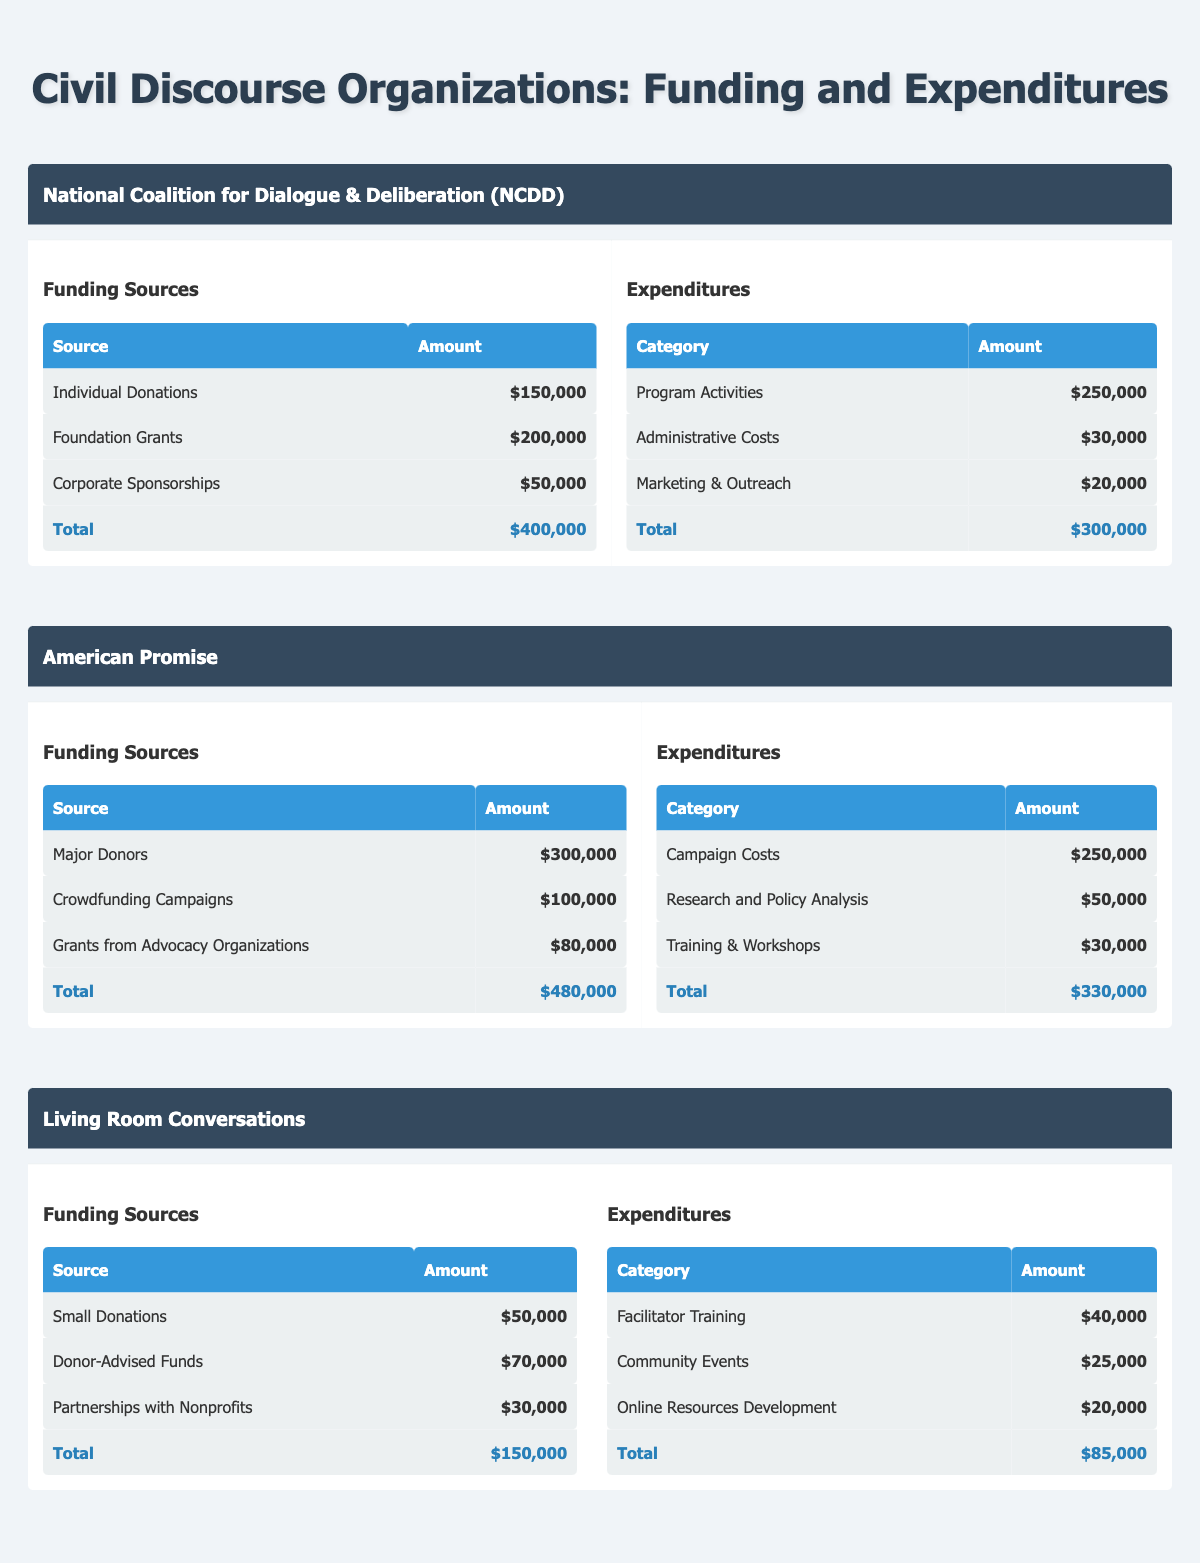What is the total funding for the National Coalition for Dialogue & Deliberation? The funding sources for NCDD are: Individual Donations ($150,000), Foundation Grants ($200,000), and Corporate Sponsorships ($50,000). Adding these amounts gives us a total of $150,000 + $200,000 + $50,000 = $400,000.
Answer: $400,000 What are the expenditures for Living Room Conversations? The expenditures for Living Room Conversations are: Facilitator Training ($40,000), Community Events ($25,000), and Online Resources Development ($20,000). Adding these amounts gives us a total of $40,000 + $25,000 + $20,000 = $85,000.
Answer: $85,000 Did American Promise receive more funding from Major Donors than from Crowdfunding Campaigns? American Promise received $300,000 from Major Donors and $100,000 from Crowdfunding Campaigns. Since $300,000 is more than $100,000, the statement is true.
Answer: Yes What is the difference between the total funding and total expenditures for the American Promise organization? The total funding for American Promise is $480,000 and the total expenditures are $330,000. The difference is calculated by subtracting expenditures from funding: $480,000 - $330,000 = $150,000.
Answer: $150,000 Which organization has the highest expenditure on Program Activities? National Coalition for Dialogue & Deliberation lists Program Activities as $250,000, while the highest expenditure in American Promise is Campaign Costs at $250,000 as well, and Living Room Conversations has expenditures that do not exceed $40,000. Therefore, both NCDD and American Promise share the highest expenditure of $250,000.
Answer: National Coalition for Dialogue & Deliberation and American Promise What is the average amount of funding received by Living Room Conversations from its three sources? Living Room Conversations received funding from Small Donations ($50,000), Donor-Advised Funds ($70,000), and Partnerships with Nonprofits ($30,000). The average is calculated by summing the amounts ($50,000 + $70,000 + $30,000 = $150,000) and dividing by the number of sources (3): $150,000 / 3 = $50,000.
Answer: $50,000 Did Living Room Conversations spend more on Community Events than on Online Resources Development? Living Room Conversations spent $25,000 on Community Events and $20,000 on Online Resources Development. Since $25,000 is greater than $20,000, the statement is true.
Answer: Yes What is the total funding received by all organizations combined? The total funding for each organization is: NCDD ($400,000) + American Promise ($480,000) + Living Room Conversations ($150,000). Adding these amounts together gives us $400,000 + $480,000 + $150,000 = $1,030,000.
Answer: $1,030,000 